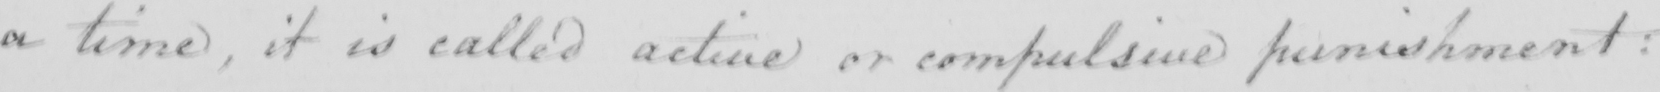What text is written in this handwritten line? a time  , it is called active or compulsive punishment : 